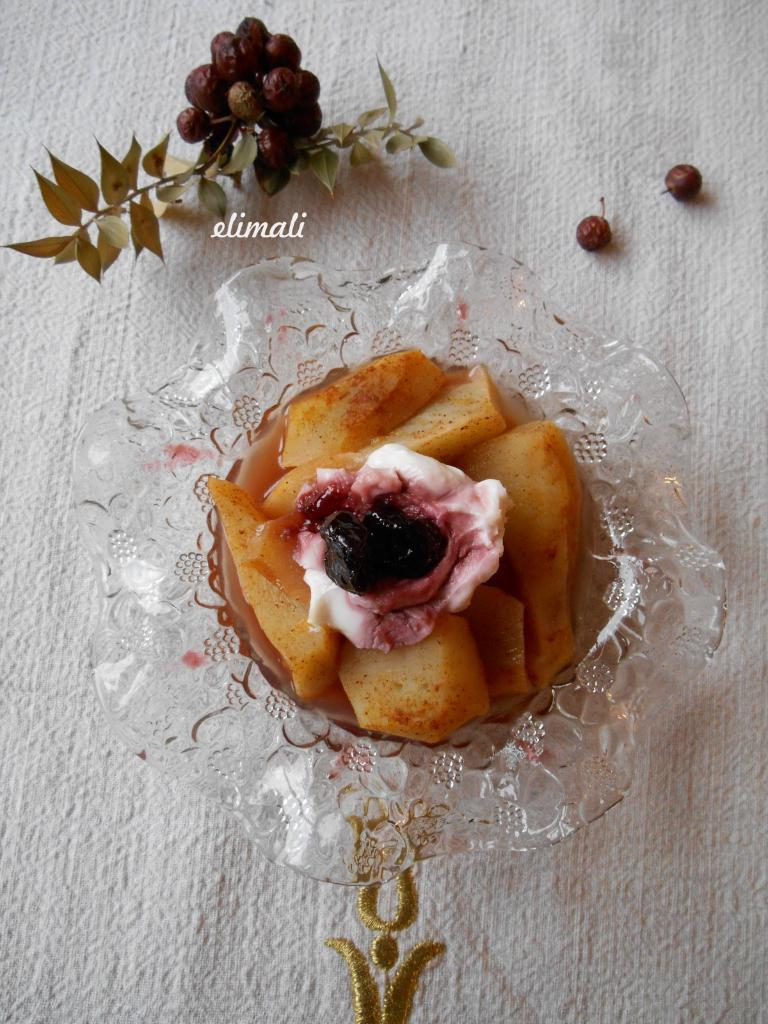What is the main subject of the image? The main subject of the image is a food item placed in a glass bowl in the center of the image. What can be seen in the background of the image? Trees and leaves are visible at the top of the image. What color is the object at the bottom of the image? There is a white color object at the bottom of the image. What type of kettle is being used to draw the attention of the tiger in the image? There is no kettle or tiger present in the image. 